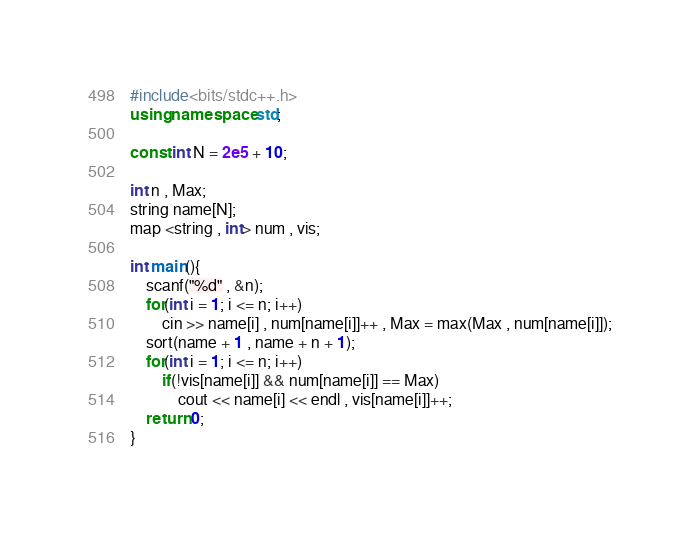<code> <loc_0><loc_0><loc_500><loc_500><_C++_>#include<bits/stdc++.h>
using namespace std;

const int N = 2e5 + 10;

int n , Max;
string name[N];
map <string , int> num , vis;

int main(){
	scanf("%d" , &n);
	for(int i = 1; i <= n; i++)
		cin >> name[i] , num[name[i]]++ , Max = max(Max , num[name[i]]);
	sort(name + 1 , name + n + 1);
	for(int i = 1; i <= n; i++)
		if(!vis[name[i]] && num[name[i]] == Max)
			cout << name[i] << endl , vis[name[i]]++;
	return 0;
}</code> 